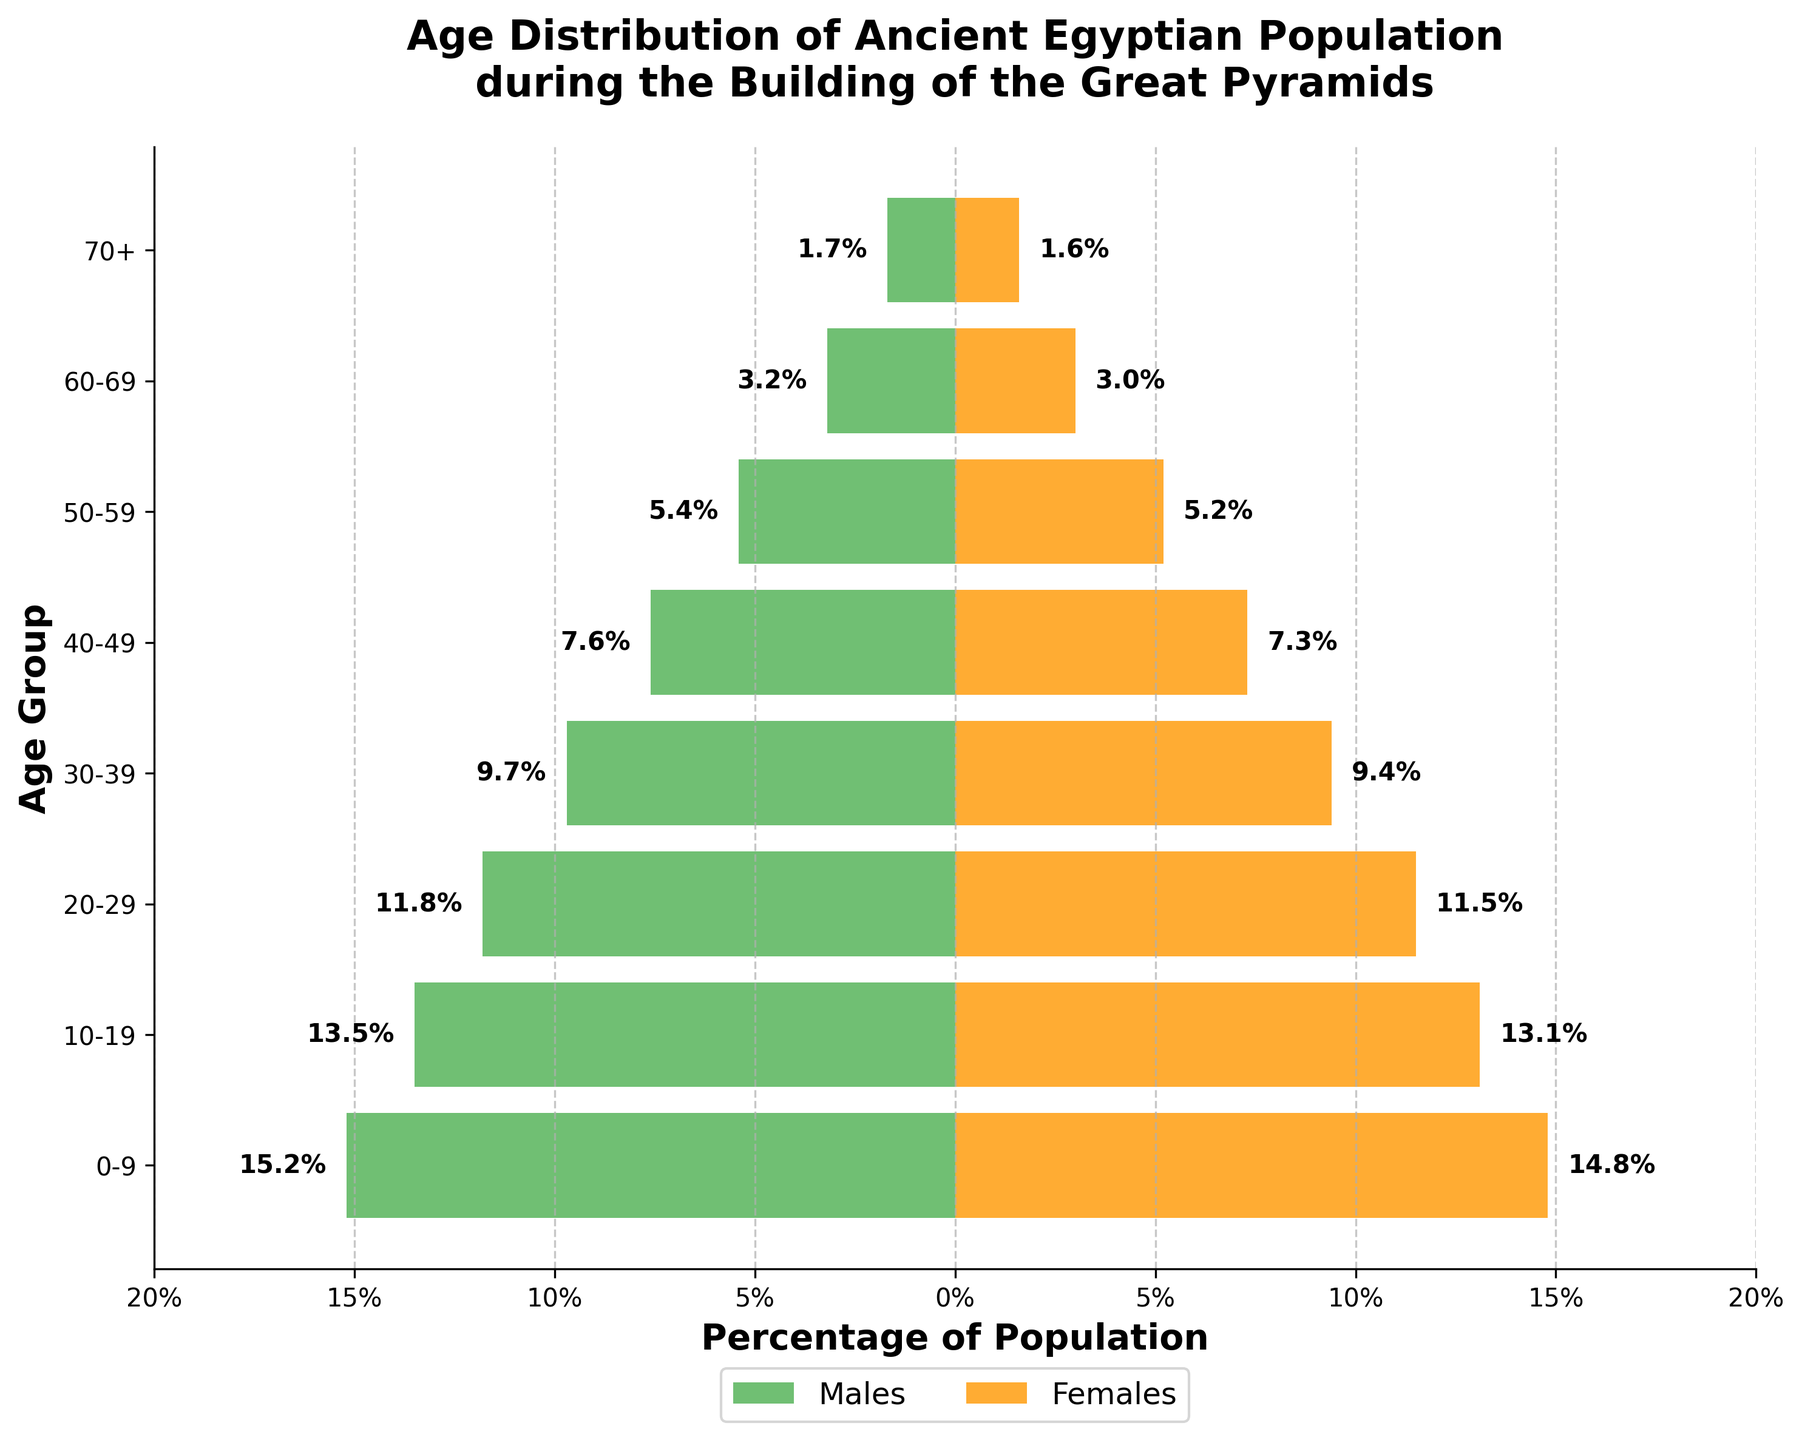What is the total percentage of the population aged 0-9? By looking at the data for the age group 0-9, combine the percentage of males (15.2%) and the percentage of females (14.8%). 15.2% + 14.8% = 30%
Answer: 30% Which age group has the smallest percentage of females? Compare the percentages of females in all age groups. The smallest percentage is 1.6% for the age group 70+.
Answer: 70+ Are there more males or females in the 20-29 age group? Compare the percentages for males (11.8%) and females (11.5%) in the 20-29 age group. 11.8% is greater than 11.5%, so there are more males.
Answer: Males What’s the percentage difference between males and females in the 30-39 age group? Subtract the percentage of females (9.4%) from the percentage of males (9.7%) for the 30-39 age group. 9.7% - 9.4% = 0.3%
Answer: 0.3% What is the combined percentage of the population aged 50-59? Add the percentage of males (5.4%) and females (5.2%) in the 50-59 age group. 5.4% + 5.2% = 10.6%
Answer: 10.6% Which gender has a greater percentage in the 70+ age group? Compare the percentage of males (1.7%) to the percentage of females (1.6%) in the 70+ age group. 1.7% is greater than 1.6%, so males have a greater percentage.
Answer: Males How does the percentage of the population in the 40-49 age group compare to the 60-69 age group? Add the percentages of males and females in each age group. For 40-49: 7.6% + 7.3% = 14.9%. For 60-69: 3.2% + 3.0% = 6.2%. The 40-49 age group has a higher percentage.
Answer: 40-49 is higher What is the average percentage of females across all age groups? Add the percentages for females in all age groups (14.8% + 13.1% + 11.5% + 9.4% + 7.3% + 5.2% + 3.0% + 1.6%) and divide by the number of groups (8). (14.8 + 13.1 + 11.5 + 9.4 + 7.3 + 5.2 + 3.0 + 1.6) / 8 = 8.49%
Answer: 8.49% How many age groups have more than 10% of both males and females? Check each age group and see if both males and females have a percentage greater than 10%. Only the 0-9 and 10-19 age groups meet this criterion.
Answer: Two 